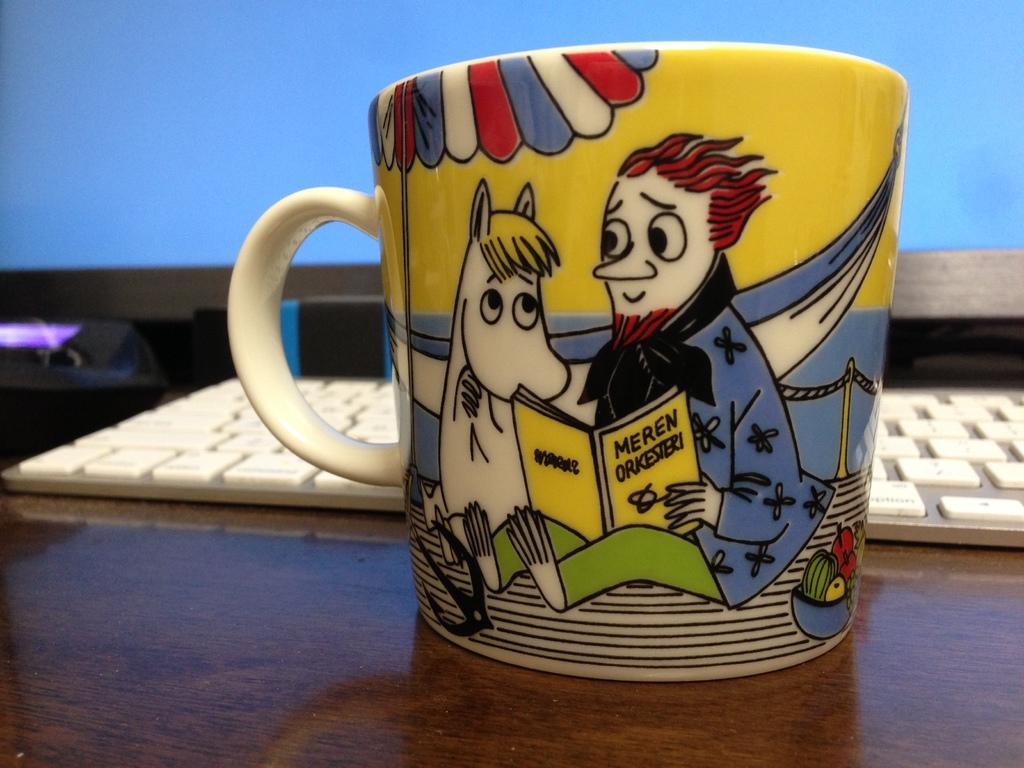<image>
Give a short and clear explanation of the subsequent image. A mug sitting on a desk that has a man reading Meren Orkesteri to a horse on it. 